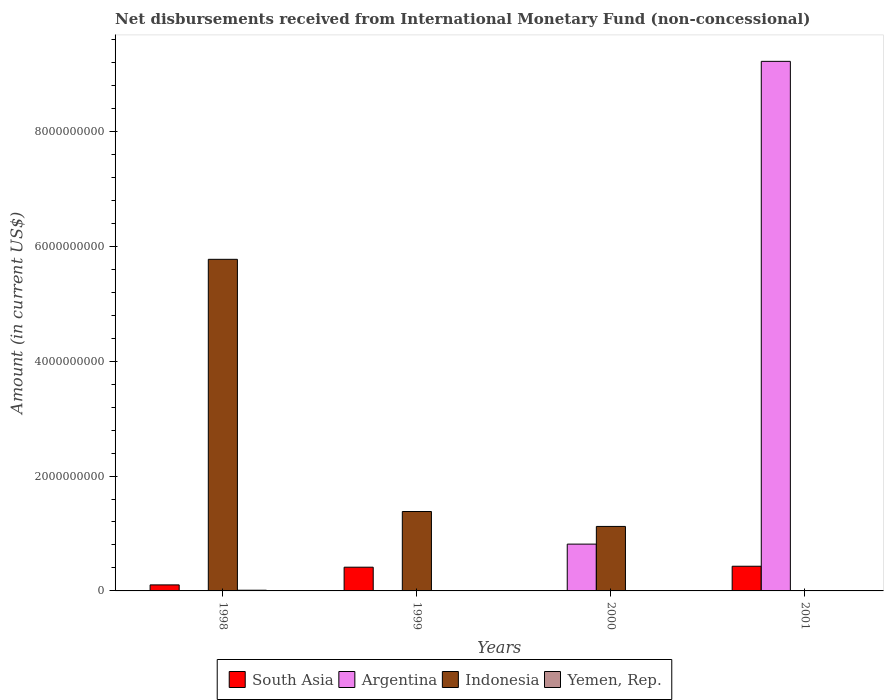Are the number of bars on each tick of the X-axis equal?
Give a very brief answer. No. In how many cases, is the number of bars for a given year not equal to the number of legend labels?
Provide a short and direct response. 4. What is the amount of disbursements received from International Monetary Fund in Yemen, Rep. in 1998?
Offer a terse response. 1.22e+07. Across all years, what is the maximum amount of disbursements received from International Monetary Fund in Indonesia?
Offer a very short reply. 5.77e+09. What is the total amount of disbursements received from International Monetary Fund in Yemen, Rep. in the graph?
Give a very brief answer. 1.22e+07. What is the difference between the amount of disbursements received from International Monetary Fund in South Asia in 1998 and that in 1999?
Your answer should be compact. -3.08e+08. What is the difference between the amount of disbursements received from International Monetary Fund in Indonesia in 1998 and the amount of disbursements received from International Monetary Fund in Yemen, Rep. in 2001?
Your answer should be very brief. 5.77e+09. What is the average amount of disbursements received from International Monetary Fund in Indonesia per year?
Your answer should be compact. 2.07e+09. In the year 1998, what is the difference between the amount of disbursements received from International Monetary Fund in Indonesia and amount of disbursements received from International Monetary Fund in South Asia?
Provide a succinct answer. 5.67e+09. What is the difference between the highest and the second highest amount of disbursements received from International Monetary Fund in South Asia?
Ensure brevity in your answer.  1.68e+07. What is the difference between the highest and the lowest amount of disbursements received from International Monetary Fund in Argentina?
Offer a terse response. 9.22e+09. In how many years, is the amount of disbursements received from International Monetary Fund in Indonesia greater than the average amount of disbursements received from International Monetary Fund in Indonesia taken over all years?
Give a very brief answer. 1. Is it the case that in every year, the sum of the amount of disbursements received from International Monetary Fund in Argentina and amount of disbursements received from International Monetary Fund in South Asia is greater than the sum of amount of disbursements received from International Monetary Fund in Yemen, Rep. and amount of disbursements received from International Monetary Fund in Indonesia?
Make the answer very short. No. Are all the bars in the graph horizontal?
Your answer should be very brief. No. Are the values on the major ticks of Y-axis written in scientific E-notation?
Your answer should be compact. No. Does the graph contain any zero values?
Your answer should be very brief. Yes. Does the graph contain grids?
Your answer should be very brief. No. How many legend labels are there?
Make the answer very short. 4. How are the legend labels stacked?
Your response must be concise. Horizontal. What is the title of the graph?
Provide a short and direct response. Net disbursements received from International Monetary Fund (non-concessional). Does "Fiji" appear as one of the legend labels in the graph?
Offer a terse response. No. What is the label or title of the Y-axis?
Your answer should be compact. Amount (in current US$). What is the Amount (in current US$) of South Asia in 1998?
Your response must be concise. 1.05e+08. What is the Amount (in current US$) in Indonesia in 1998?
Your response must be concise. 5.77e+09. What is the Amount (in current US$) of Yemen, Rep. in 1998?
Provide a succinct answer. 1.22e+07. What is the Amount (in current US$) of South Asia in 1999?
Your answer should be very brief. 4.13e+08. What is the Amount (in current US$) of Indonesia in 1999?
Give a very brief answer. 1.38e+09. What is the Amount (in current US$) in Argentina in 2000?
Give a very brief answer. 8.15e+08. What is the Amount (in current US$) of Indonesia in 2000?
Provide a succinct answer. 1.12e+09. What is the Amount (in current US$) of Yemen, Rep. in 2000?
Provide a short and direct response. 0. What is the Amount (in current US$) in South Asia in 2001?
Make the answer very short. 4.30e+08. What is the Amount (in current US$) in Argentina in 2001?
Offer a terse response. 9.22e+09. Across all years, what is the maximum Amount (in current US$) in South Asia?
Give a very brief answer. 4.30e+08. Across all years, what is the maximum Amount (in current US$) of Argentina?
Offer a very short reply. 9.22e+09. Across all years, what is the maximum Amount (in current US$) of Indonesia?
Your response must be concise. 5.77e+09. Across all years, what is the maximum Amount (in current US$) in Yemen, Rep.?
Your answer should be compact. 1.22e+07. Across all years, what is the minimum Amount (in current US$) in South Asia?
Your response must be concise. 0. Across all years, what is the minimum Amount (in current US$) in Indonesia?
Offer a very short reply. 0. What is the total Amount (in current US$) in South Asia in the graph?
Your answer should be very brief. 9.48e+08. What is the total Amount (in current US$) in Argentina in the graph?
Offer a very short reply. 1.00e+1. What is the total Amount (in current US$) of Indonesia in the graph?
Offer a very short reply. 8.28e+09. What is the total Amount (in current US$) in Yemen, Rep. in the graph?
Your answer should be compact. 1.22e+07. What is the difference between the Amount (in current US$) of South Asia in 1998 and that in 1999?
Make the answer very short. -3.08e+08. What is the difference between the Amount (in current US$) in Indonesia in 1998 and that in 1999?
Provide a short and direct response. 4.39e+09. What is the difference between the Amount (in current US$) in Indonesia in 1998 and that in 2000?
Your response must be concise. 4.65e+09. What is the difference between the Amount (in current US$) in South Asia in 1998 and that in 2001?
Your response must be concise. -3.25e+08. What is the difference between the Amount (in current US$) in Indonesia in 1999 and that in 2000?
Offer a very short reply. 2.60e+08. What is the difference between the Amount (in current US$) of South Asia in 1999 and that in 2001?
Provide a short and direct response. -1.68e+07. What is the difference between the Amount (in current US$) in Argentina in 2000 and that in 2001?
Ensure brevity in your answer.  -8.40e+09. What is the difference between the Amount (in current US$) in South Asia in 1998 and the Amount (in current US$) in Indonesia in 1999?
Offer a very short reply. -1.28e+09. What is the difference between the Amount (in current US$) of South Asia in 1998 and the Amount (in current US$) of Argentina in 2000?
Provide a short and direct response. -7.10e+08. What is the difference between the Amount (in current US$) of South Asia in 1998 and the Amount (in current US$) of Indonesia in 2000?
Keep it short and to the point. -1.02e+09. What is the difference between the Amount (in current US$) in South Asia in 1998 and the Amount (in current US$) in Argentina in 2001?
Provide a short and direct response. -9.11e+09. What is the difference between the Amount (in current US$) in South Asia in 1999 and the Amount (in current US$) in Argentina in 2000?
Ensure brevity in your answer.  -4.02e+08. What is the difference between the Amount (in current US$) in South Asia in 1999 and the Amount (in current US$) in Indonesia in 2000?
Your answer should be compact. -7.10e+08. What is the difference between the Amount (in current US$) of South Asia in 1999 and the Amount (in current US$) of Argentina in 2001?
Give a very brief answer. -8.81e+09. What is the average Amount (in current US$) in South Asia per year?
Make the answer very short. 2.37e+08. What is the average Amount (in current US$) in Argentina per year?
Your answer should be compact. 2.51e+09. What is the average Amount (in current US$) in Indonesia per year?
Make the answer very short. 2.07e+09. What is the average Amount (in current US$) of Yemen, Rep. per year?
Give a very brief answer. 3.05e+06. In the year 1998, what is the difference between the Amount (in current US$) of South Asia and Amount (in current US$) of Indonesia?
Provide a short and direct response. -5.67e+09. In the year 1998, what is the difference between the Amount (in current US$) in South Asia and Amount (in current US$) in Yemen, Rep.?
Make the answer very short. 9.28e+07. In the year 1998, what is the difference between the Amount (in current US$) of Indonesia and Amount (in current US$) of Yemen, Rep.?
Your response must be concise. 5.76e+09. In the year 1999, what is the difference between the Amount (in current US$) in South Asia and Amount (in current US$) in Indonesia?
Offer a very short reply. -9.70e+08. In the year 2000, what is the difference between the Amount (in current US$) of Argentina and Amount (in current US$) of Indonesia?
Ensure brevity in your answer.  -3.08e+08. In the year 2001, what is the difference between the Amount (in current US$) in South Asia and Amount (in current US$) in Argentina?
Offer a very short reply. -8.79e+09. What is the ratio of the Amount (in current US$) of South Asia in 1998 to that in 1999?
Offer a terse response. 0.25. What is the ratio of the Amount (in current US$) in Indonesia in 1998 to that in 1999?
Offer a terse response. 4.18. What is the ratio of the Amount (in current US$) of Indonesia in 1998 to that in 2000?
Offer a very short reply. 5.14. What is the ratio of the Amount (in current US$) of South Asia in 1998 to that in 2001?
Your answer should be compact. 0.24. What is the ratio of the Amount (in current US$) in Indonesia in 1999 to that in 2000?
Provide a succinct answer. 1.23. What is the ratio of the Amount (in current US$) in South Asia in 1999 to that in 2001?
Provide a succinct answer. 0.96. What is the ratio of the Amount (in current US$) in Argentina in 2000 to that in 2001?
Your answer should be very brief. 0.09. What is the difference between the highest and the second highest Amount (in current US$) in South Asia?
Offer a terse response. 1.68e+07. What is the difference between the highest and the second highest Amount (in current US$) in Indonesia?
Offer a very short reply. 4.39e+09. What is the difference between the highest and the lowest Amount (in current US$) in South Asia?
Ensure brevity in your answer.  4.30e+08. What is the difference between the highest and the lowest Amount (in current US$) of Argentina?
Your answer should be compact. 9.22e+09. What is the difference between the highest and the lowest Amount (in current US$) of Indonesia?
Give a very brief answer. 5.77e+09. What is the difference between the highest and the lowest Amount (in current US$) in Yemen, Rep.?
Keep it short and to the point. 1.22e+07. 